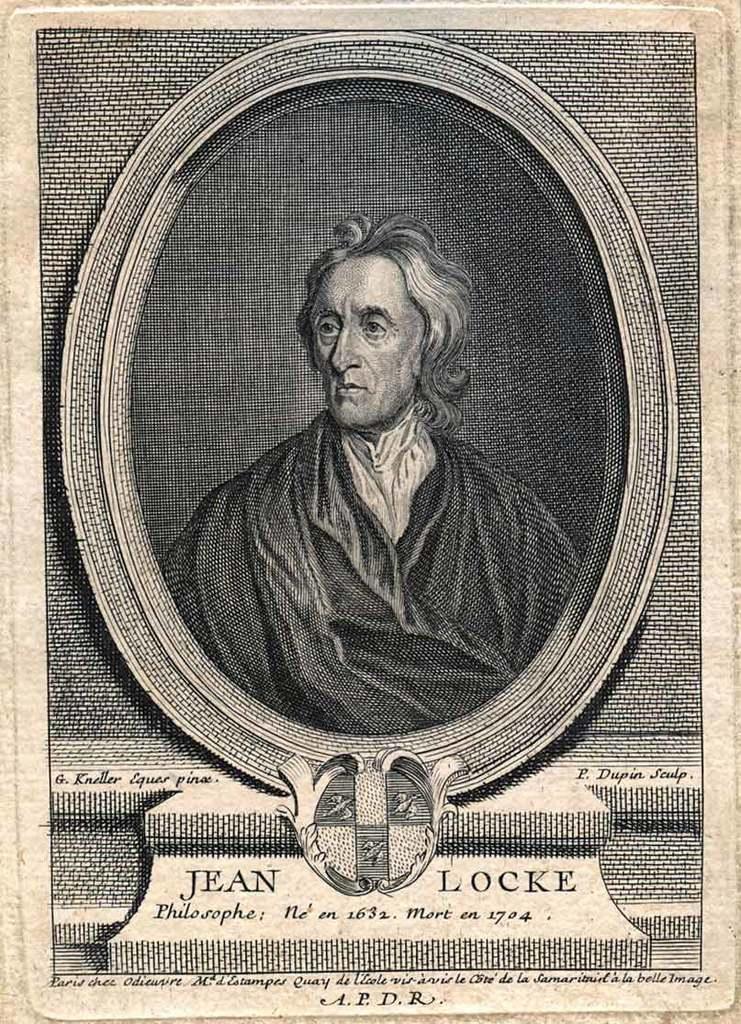What is this philosopher's name?
Your answer should be very brief. Jean locke. When did locke die?
Give a very brief answer. 1704. 